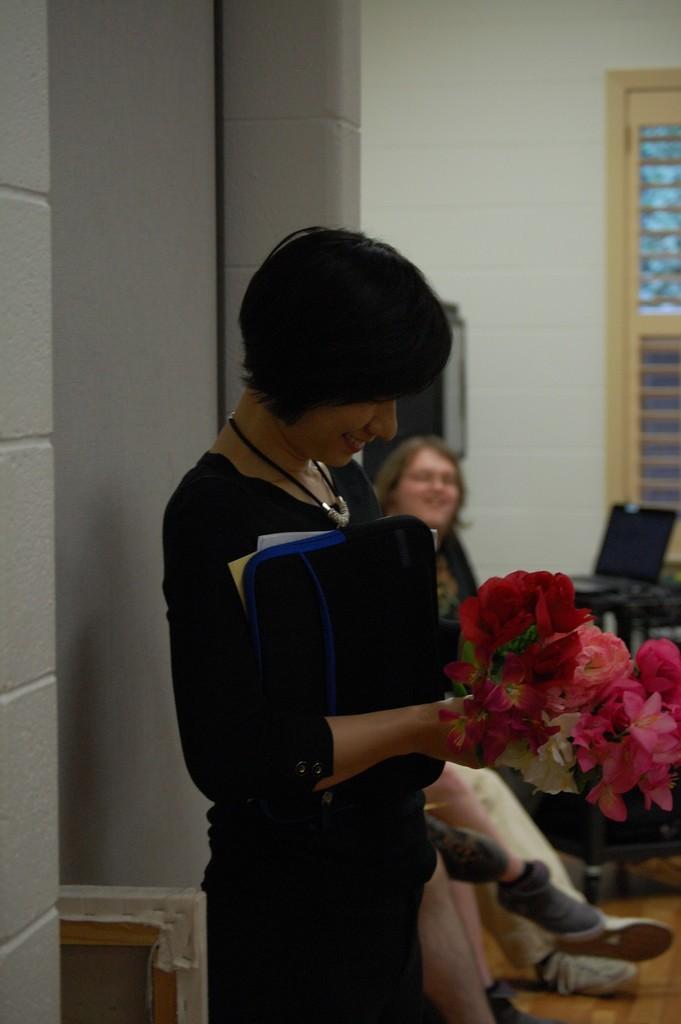Could you give a brief overview of what you see in this image? In this image we can see a woman is standing, and smiling, she is holding flowers in the hand, at beside here a woman is sitting, here is the laptop on the table, here is the wall. 